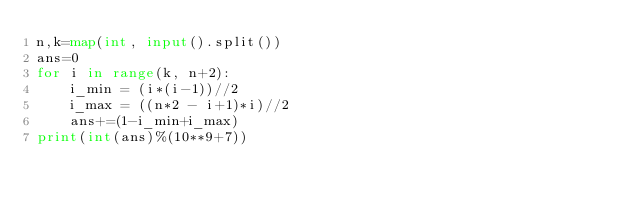<code> <loc_0><loc_0><loc_500><loc_500><_Python_>n,k=map(int, input().split())
ans=0
for i in range(k, n+2):
    i_min = (i*(i-1))//2
    i_max = ((n*2 - i+1)*i)//2
    ans+=(1-i_min+i_max)
print(int(ans)%(10**9+7))
</code> 